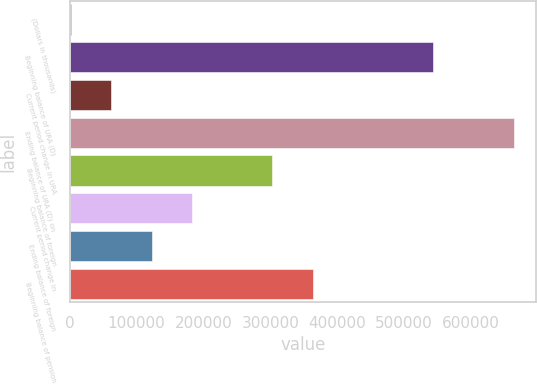<chart> <loc_0><loc_0><loc_500><loc_500><bar_chart><fcel>(Dollars in thousands)<fcel>Beginning balance of URA (D)<fcel>Current period change in URA<fcel>Ending balance of URA (D) on<fcel>Beginning balance of foreign<fcel>Current period change in<fcel>Ending balance of foreign<fcel>Beginning balance of pension<nl><fcel>2012<fcel>543736<fcel>62203.6<fcel>664120<fcel>302970<fcel>182587<fcel>122395<fcel>363162<nl></chart> 